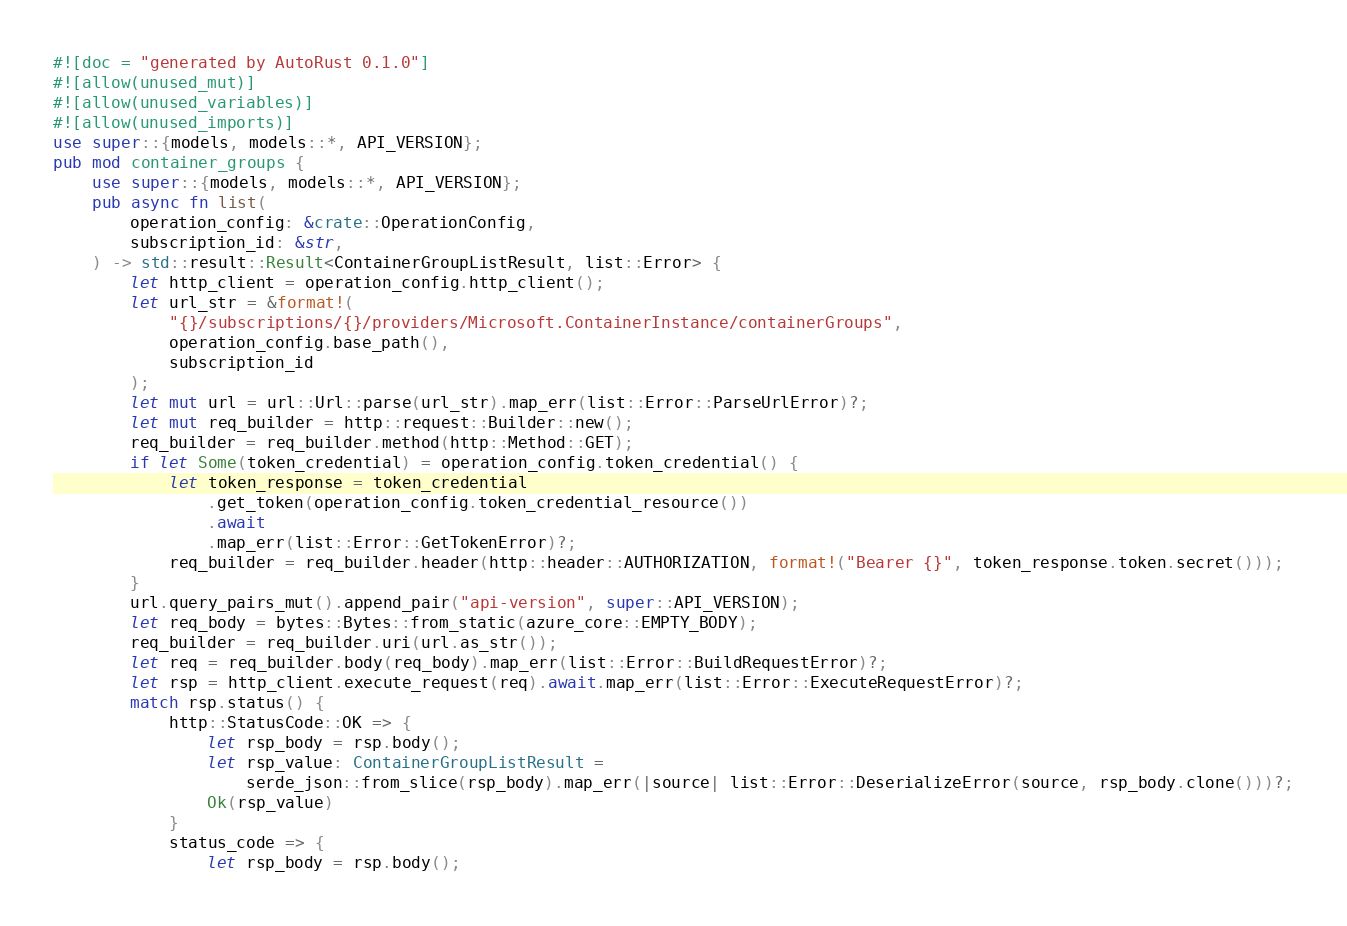<code> <loc_0><loc_0><loc_500><loc_500><_Rust_>#![doc = "generated by AutoRust 0.1.0"]
#![allow(unused_mut)]
#![allow(unused_variables)]
#![allow(unused_imports)]
use super::{models, models::*, API_VERSION};
pub mod container_groups {
    use super::{models, models::*, API_VERSION};
    pub async fn list(
        operation_config: &crate::OperationConfig,
        subscription_id: &str,
    ) -> std::result::Result<ContainerGroupListResult, list::Error> {
        let http_client = operation_config.http_client();
        let url_str = &format!(
            "{}/subscriptions/{}/providers/Microsoft.ContainerInstance/containerGroups",
            operation_config.base_path(),
            subscription_id
        );
        let mut url = url::Url::parse(url_str).map_err(list::Error::ParseUrlError)?;
        let mut req_builder = http::request::Builder::new();
        req_builder = req_builder.method(http::Method::GET);
        if let Some(token_credential) = operation_config.token_credential() {
            let token_response = token_credential
                .get_token(operation_config.token_credential_resource())
                .await
                .map_err(list::Error::GetTokenError)?;
            req_builder = req_builder.header(http::header::AUTHORIZATION, format!("Bearer {}", token_response.token.secret()));
        }
        url.query_pairs_mut().append_pair("api-version", super::API_VERSION);
        let req_body = bytes::Bytes::from_static(azure_core::EMPTY_BODY);
        req_builder = req_builder.uri(url.as_str());
        let req = req_builder.body(req_body).map_err(list::Error::BuildRequestError)?;
        let rsp = http_client.execute_request(req).await.map_err(list::Error::ExecuteRequestError)?;
        match rsp.status() {
            http::StatusCode::OK => {
                let rsp_body = rsp.body();
                let rsp_value: ContainerGroupListResult =
                    serde_json::from_slice(rsp_body).map_err(|source| list::Error::DeserializeError(source, rsp_body.clone()))?;
                Ok(rsp_value)
            }
            status_code => {
                let rsp_body = rsp.body();</code> 